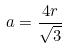<formula> <loc_0><loc_0><loc_500><loc_500>a = \frac { 4 r } { \sqrt { 3 } }</formula> 